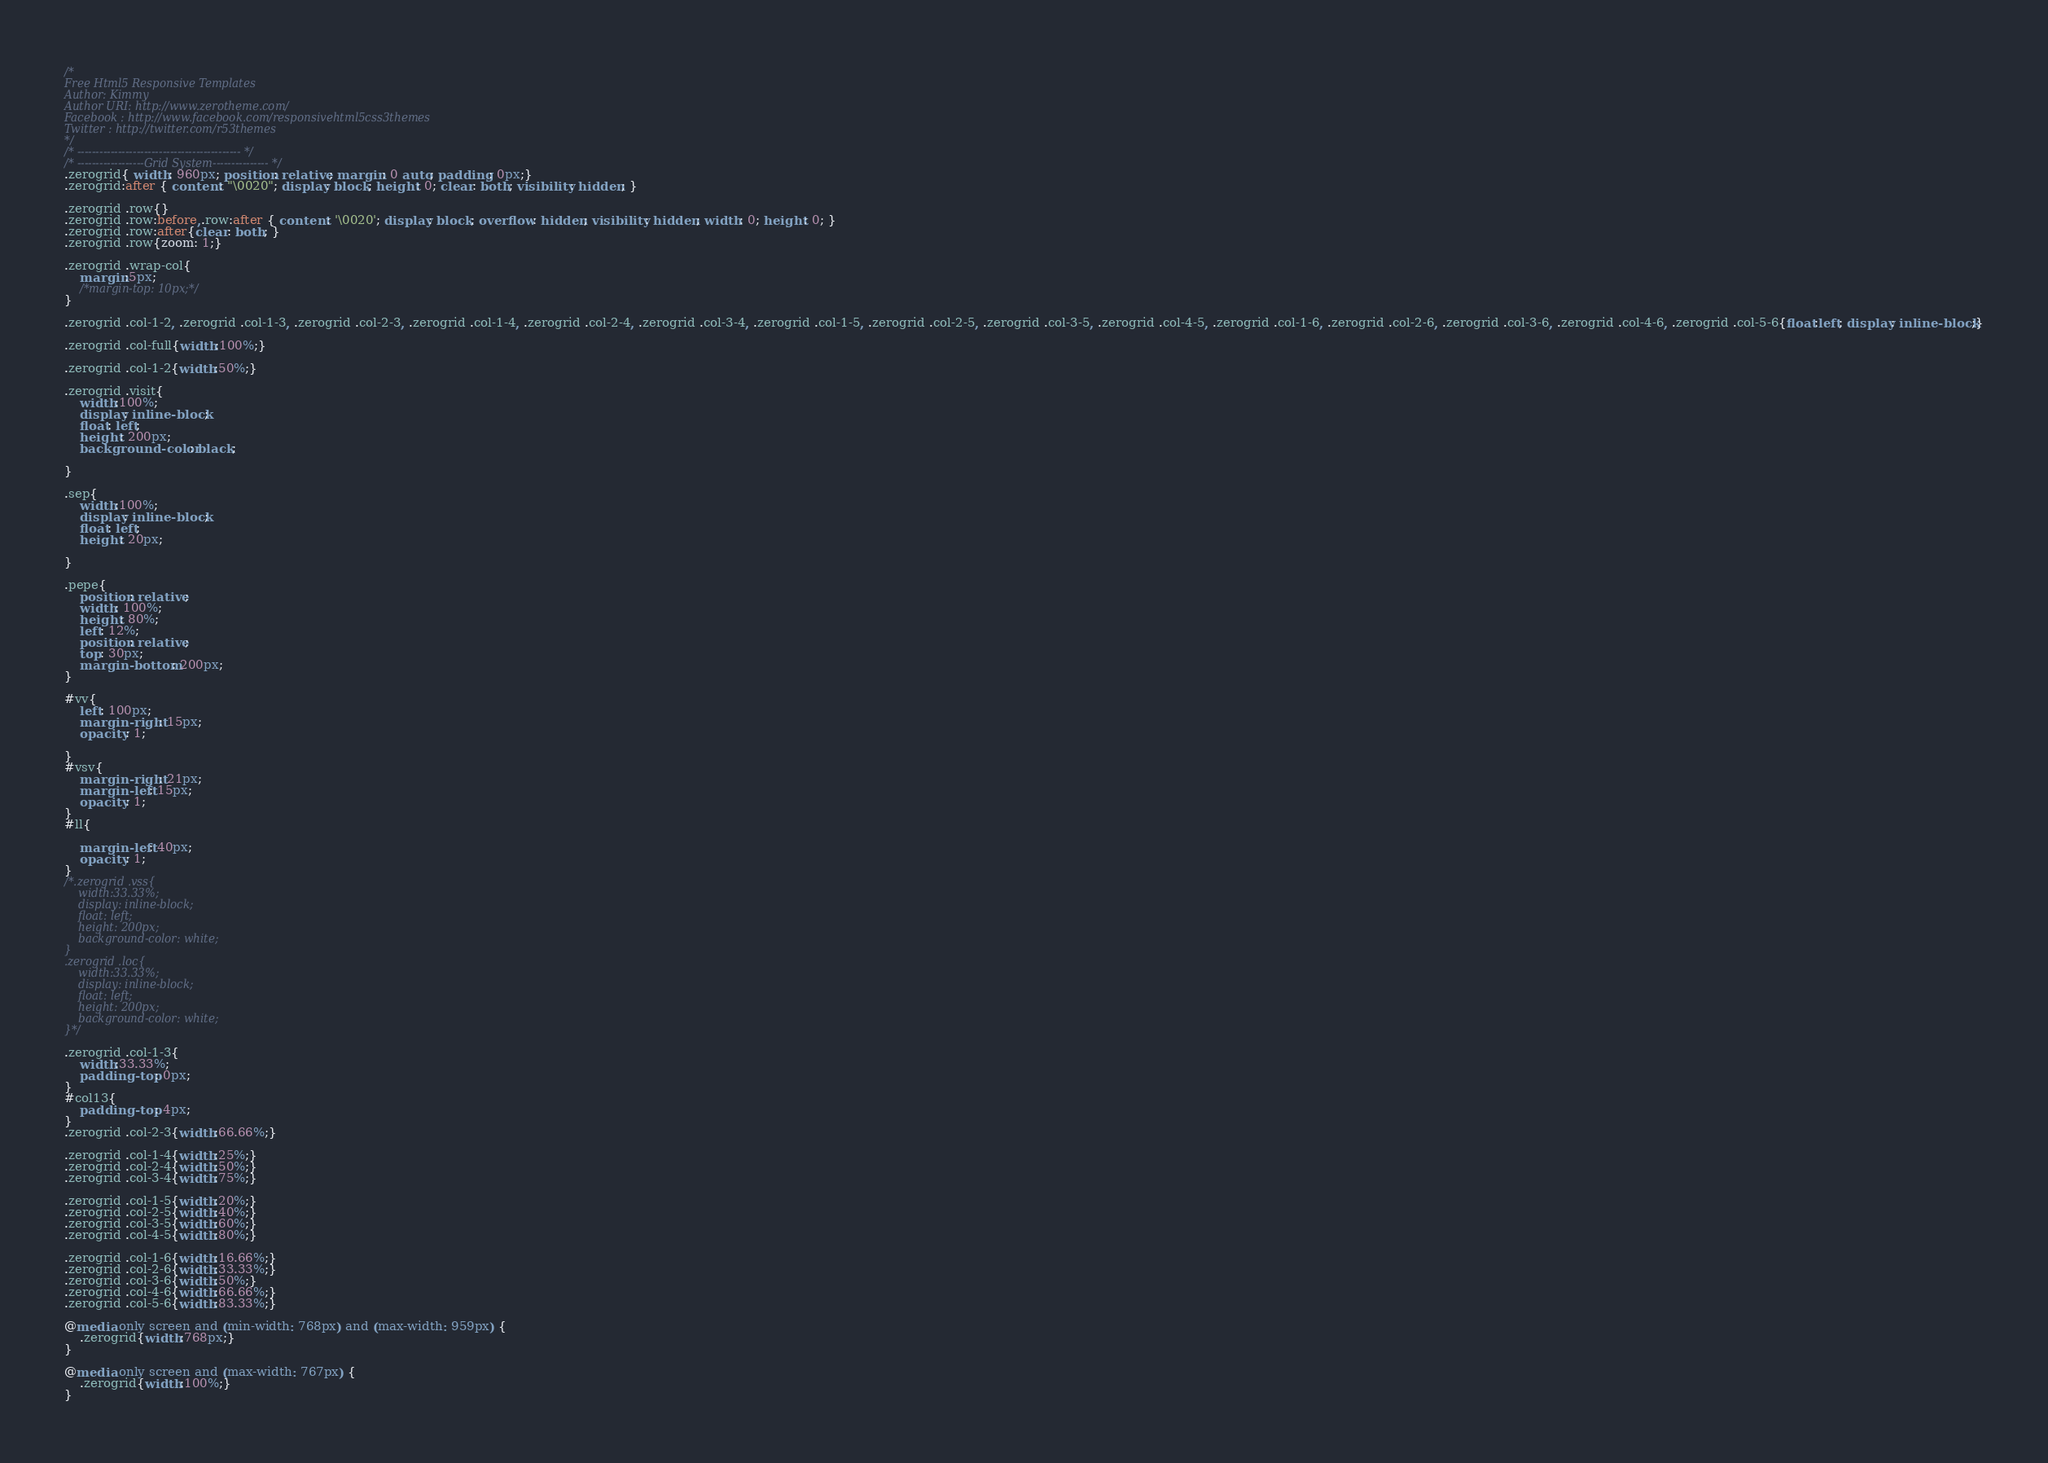<code> <loc_0><loc_0><loc_500><loc_500><_CSS_>/*
Free Html5 Responsive Templates
Author: Kimmy
Author URI: http://www.zerotheme.com/
Facebook : http://www.facebook.com/responsivehtml5css3themes
Twitter : http://twitter.com/r53themes
*/
/* -------------------------------------------- */
/* ------------------Grid System--------------- */ 
.zerogrid{ width: 960px; position: relative; margin: 0 auto; padding: 0px;}
.zerogrid:after { content: "\0020"; display: block; height: 0; clear: both; visibility: hidden; }

.zerogrid .row{}
.zerogrid .row:before,.row:after { content: '\0020'; display: block; overflow: hidden; visibility: hidden; width: 0; height: 0; }
.zerogrid .row:after{clear: both; }
.zerogrid .row{zoom: 1;}

.zerogrid .wrap-col{
	margin:5px;
	/*margin-top: 10px;*/
}

.zerogrid .col-1-2, .zerogrid .col-1-3, .zerogrid .col-2-3, .zerogrid .col-1-4, .zerogrid .col-2-4, .zerogrid .col-3-4, .zerogrid .col-1-5, .zerogrid .col-2-5, .zerogrid .col-3-5, .zerogrid .col-4-5, .zerogrid .col-1-6, .zerogrid .col-2-6, .zerogrid .col-3-6, .zerogrid .col-4-6, .zerogrid .col-5-6{float:left; display: inline-block;}

.zerogrid .col-full{width:100%;}

.zerogrid .col-1-2{width:50%;}

.zerogrid .visit{
	width:100%;
	display: inline-block;
	float: left;
	height: 200px;
	background-color: black;
	
}

.sep{
	width:100%;
	display: inline-block;
	float: left;
	height: 20px;

}

.pepe{
	position: relative;
	width: 100%;
	height: 80%;
	left: 12%;
	position: relative;
	top: 30px;
	margin-bottom: 200px;
}

#vv{
	left: 100px;
	margin-right: 15px;
	opacity: 1;

}
#vsv{
	margin-right: 21px;
	margin-left: 15px;
	opacity: 1;
}
#ll{
	
	margin-left: 40px;
	opacity: 1;
}
/*.zerogrid .vss{
	width:33.33%;
	display: inline-block;
	float: left;
	height: 200px;
	background-color: white;
}
.zerogrid .loc{
	width:33.33%;
	display: inline-block;
	float: left;
	height: 200px;
	background-color: white;
}*/

.zerogrid .col-1-3{
	width:33.33%;
	padding-top: 0px;
}
#col13{
	padding-top: 4px;
}
.zerogrid .col-2-3{width:66.66%;}

.zerogrid .col-1-4{width:25%;}
.zerogrid .col-2-4{width:50%;}
.zerogrid .col-3-4{width:75%;}

.zerogrid .col-1-5{width:20%;}
.zerogrid .col-2-5{width:40%;}
.zerogrid .col-3-5{width:60%;}
.zerogrid .col-4-5{width:80%;}

.zerogrid .col-1-6{width:16.66%;}
.zerogrid .col-2-6{width:33.33%;}
.zerogrid .col-3-6{width:50%;}
.zerogrid .col-4-6{width:66.66%;}
.zerogrid .col-5-6{width:83.33%;}

@media only screen and (min-width: 768px) and (max-width: 959px) {
	.zerogrid{width:768px;}
}

@media only screen and (max-width: 767px) {
	.zerogrid{width:100%;}
}
</code> 